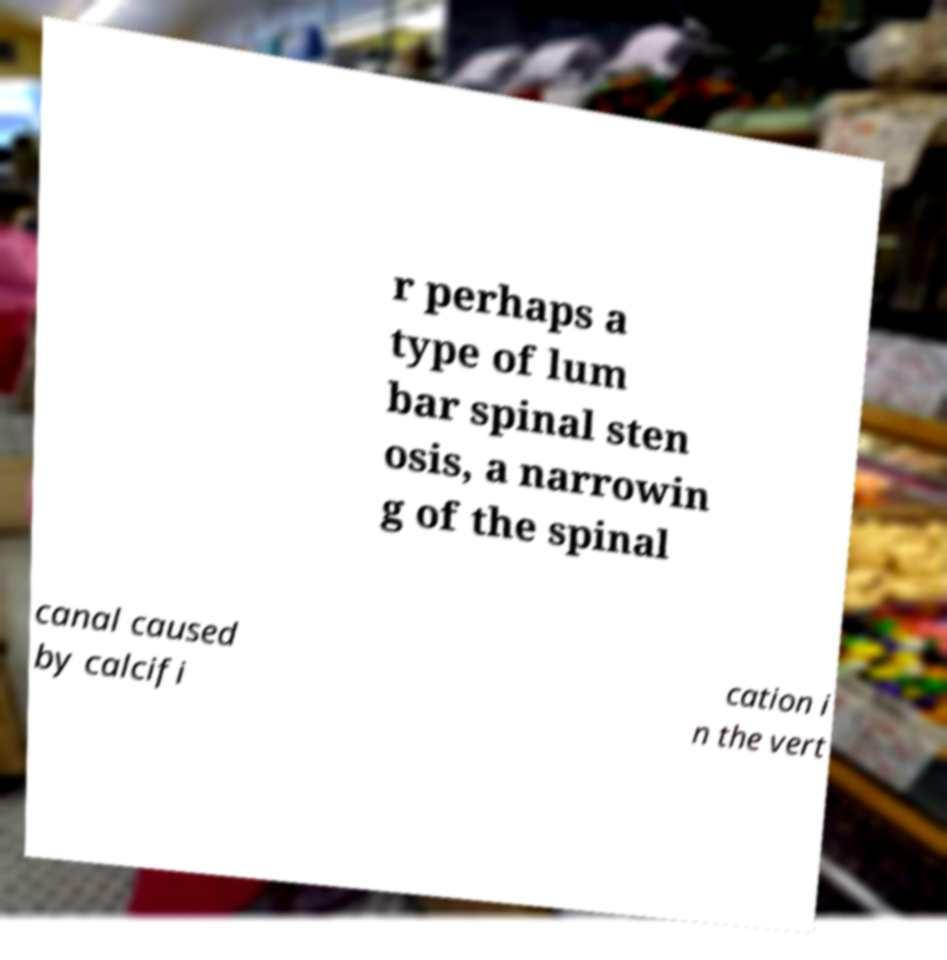Please identify and transcribe the text found in this image. r perhaps a type of lum bar spinal sten osis, a narrowin g of the spinal canal caused by calcifi cation i n the vert 